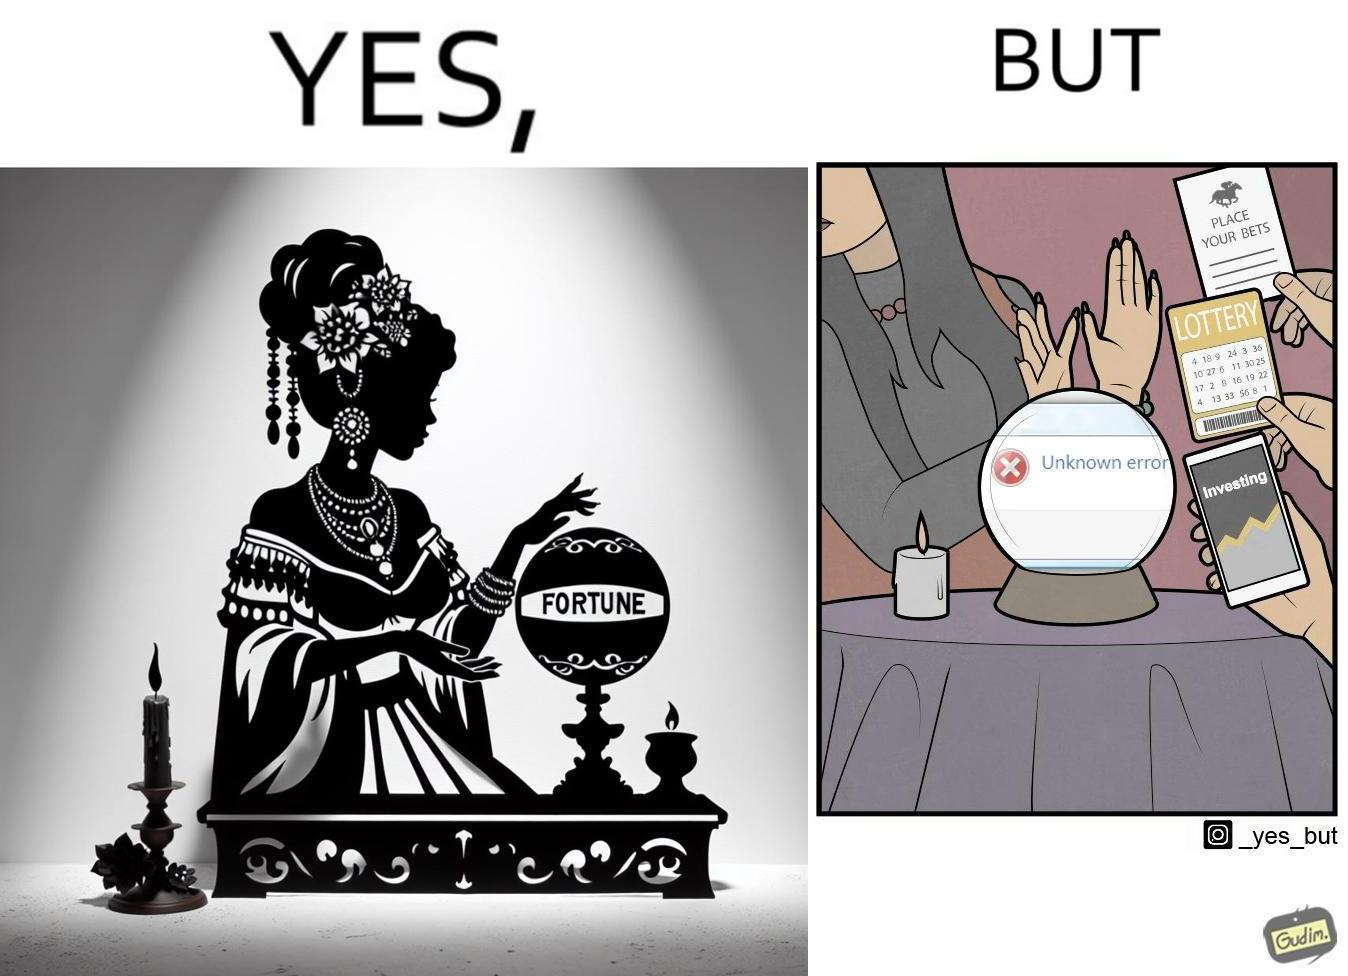Describe the content of this image. The people who claim to predict the future either find their predictions unsuccessful or avoid themselves from making claims related to finance, lotteries, and bets. 